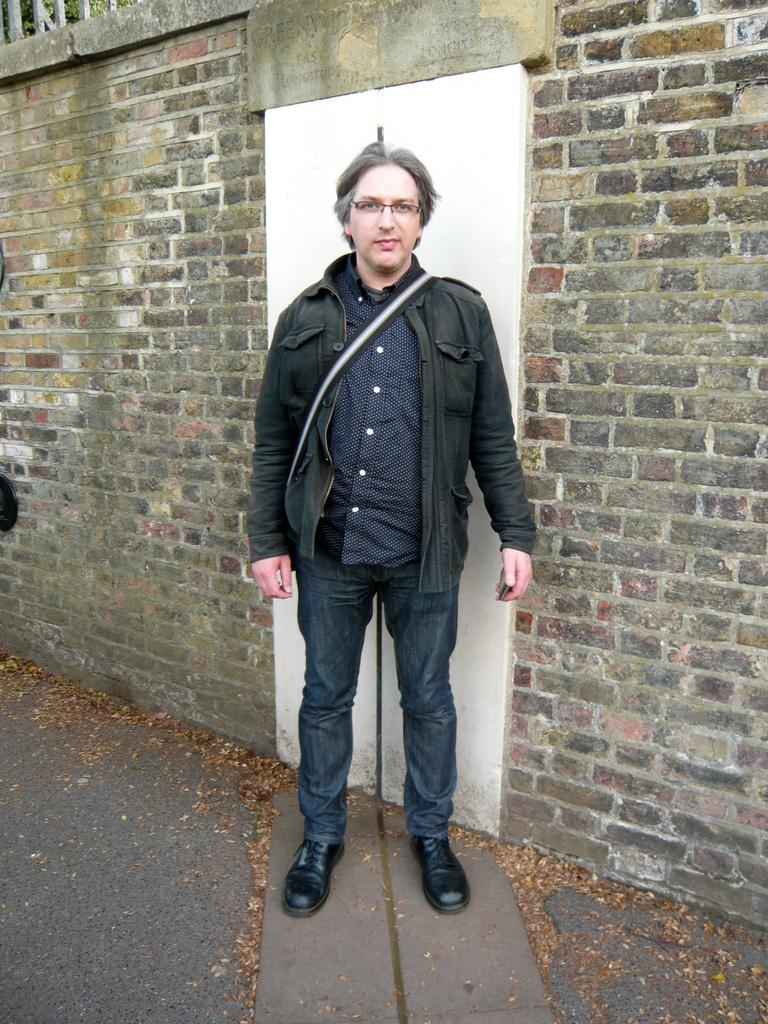What is the main subject of the image? There is a man standing in the image. What is the man wearing in the image? The man is wearing a bag. What can be seen in the image besides the man? There is a door in the image. What is visible in the background of the image? There is a brick wall in the background of the image. Can you see the man attempting to run with a banana in the image? There is no banana or running depicted in the image; it only shows a man standing with a bag and a door with a brick wall in the background. 